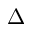<formula> <loc_0><loc_0><loc_500><loc_500>\Delta</formula> 